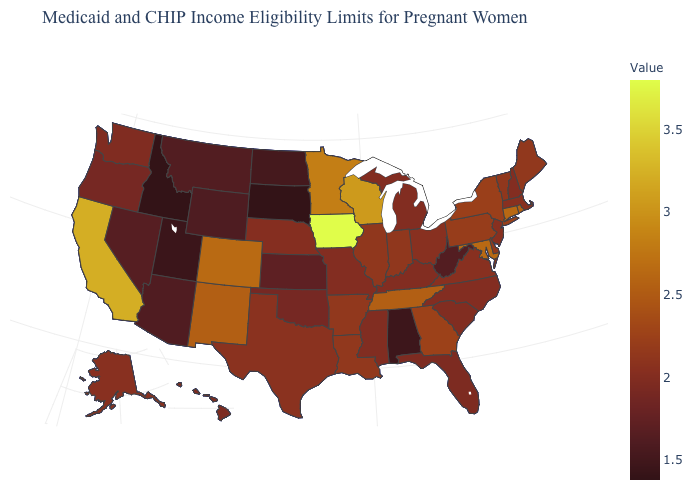Among the states that border Arizona , which have the highest value?
Short answer required. California. Which states have the lowest value in the USA?
Quick response, please. Idaho, South Dakota. Among the states that border Oregon , does California have the lowest value?
Write a very short answer. No. Does Texas have the lowest value in the USA?
Concise answer only. No. 